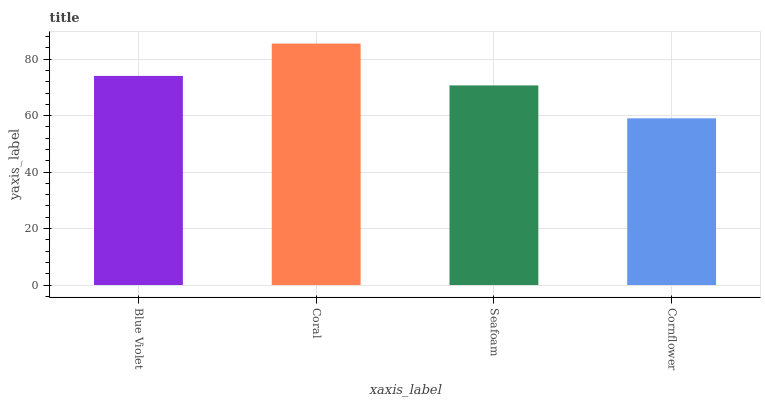Is Seafoam the minimum?
Answer yes or no. No. Is Seafoam the maximum?
Answer yes or no. No. Is Coral greater than Seafoam?
Answer yes or no. Yes. Is Seafoam less than Coral?
Answer yes or no. Yes. Is Seafoam greater than Coral?
Answer yes or no. No. Is Coral less than Seafoam?
Answer yes or no. No. Is Blue Violet the high median?
Answer yes or no. Yes. Is Seafoam the low median?
Answer yes or no. Yes. Is Coral the high median?
Answer yes or no. No. Is Blue Violet the low median?
Answer yes or no. No. 